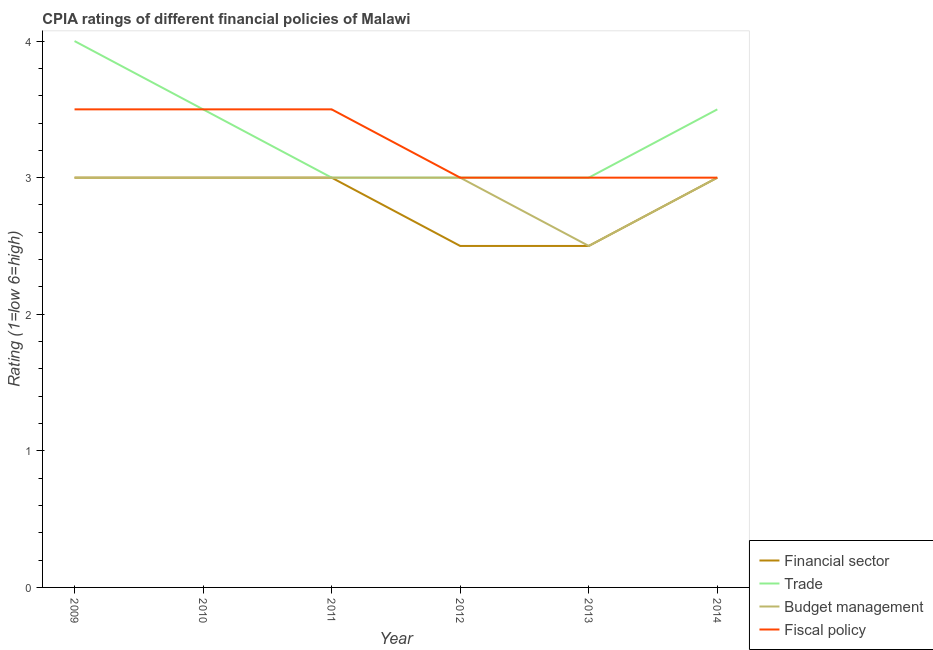Does the line corresponding to cpia rating of budget management intersect with the line corresponding to cpia rating of financial sector?
Your answer should be very brief. Yes. Is the number of lines equal to the number of legend labels?
Make the answer very short. Yes. Across all years, what is the maximum cpia rating of budget management?
Offer a very short reply. 3. In which year was the cpia rating of fiscal policy maximum?
Provide a succinct answer. 2009. What is the difference between the cpia rating of fiscal policy in 2009 and that in 2012?
Provide a succinct answer. 0.5. What is the difference between the cpia rating of budget management in 2014 and the cpia rating of trade in 2012?
Your answer should be very brief. 0. What is the average cpia rating of budget management per year?
Ensure brevity in your answer.  2.92. In the year 2009, what is the difference between the cpia rating of trade and cpia rating of financial sector?
Your answer should be compact. 1. In how many years, is the cpia rating of fiscal policy greater than 0.8?
Your answer should be compact. 6. What is the ratio of the cpia rating of trade in 2009 to that in 2011?
Offer a terse response. 1.33. Is the cpia rating of financial sector in 2010 less than that in 2012?
Make the answer very short. No. Is it the case that in every year, the sum of the cpia rating of fiscal policy and cpia rating of budget management is greater than the sum of cpia rating of trade and cpia rating of financial sector?
Your answer should be very brief. No. Is it the case that in every year, the sum of the cpia rating of financial sector and cpia rating of trade is greater than the cpia rating of budget management?
Offer a very short reply. Yes. Does the cpia rating of financial sector monotonically increase over the years?
Make the answer very short. No. Is the cpia rating of budget management strictly greater than the cpia rating of financial sector over the years?
Offer a very short reply. No. Is the cpia rating of trade strictly less than the cpia rating of financial sector over the years?
Offer a very short reply. No. How many lines are there?
Your response must be concise. 4. How many years are there in the graph?
Make the answer very short. 6. What is the difference between two consecutive major ticks on the Y-axis?
Your response must be concise. 1. What is the title of the graph?
Keep it short and to the point. CPIA ratings of different financial policies of Malawi. Does "Methodology assessment" appear as one of the legend labels in the graph?
Ensure brevity in your answer.  No. What is the Rating (1=low 6=high) in Fiscal policy in 2009?
Your answer should be very brief. 3.5. What is the Rating (1=low 6=high) of Financial sector in 2010?
Your response must be concise. 3. What is the Rating (1=low 6=high) of Financial sector in 2011?
Offer a very short reply. 3. What is the Rating (1=low 6=high) in Trade in 2011?
Your answer should be very brief. 3. What is the Rating (1=low 6=high) of Financial sector in 2012?
Provide a succinct answer. 2.5. What is the Rating (1=low 6=high) of Budget management in 2012?
Keep it short and to the point. 3. What is the Rating (1=low 6=high) of Financial sector in 2013?
Offer a terse response. 2.5. What is the Rating (1=low 6=high) of Financial sector in 2014?
Keep it short and to the point. 3. What is the Rating (1=low 6=high) of Budget management in 2014?
Give a very brief answer. 3. What is the Rating (1=low 6=high) of Fiscal policy in 2014?
Keep it short and to the point. 3. Across all years, what is the maximum Rating (1=low 6=high) in Financial sector?
Offer a very short reply. 3. Across all years, what is the maximum Rating (1=low 6=high) of Trade?
Ensure brevity in your answer.  4. Across all years, what is the maximum Rating (1=low 6=high) of Budget management?
Ensure brevity in your answer.  3. Across all years, what is the minimum Rating (1=low 6=high) of Financial sector?
Your answer should be compact. 2.5. Across all years, what is the minimum Rating (1=low 6=high) in Fiscal policy?
Your answer should be very brief. 3. What is the total Rating (1=low 6=high) of Trade in the graph?
Provide a short and direct response. 20. What is the total Rating (1=low 6=high) in Budget management in the graph?
Keep it short and to the point. 17.5. What is the difference between the Rating (1=low 6=high) in Financial sector in 2009 and that in 2011?
Offer a very short reply. 0. What is the difference between the Rating (1=low 6=high) of Budget management in 2009 and that in 2011?
Give a very brief answer. 0. What is the difference between the Rating (1=low 6=high) of Fiscal policy in 2009 and that in 2011?
Make the answer very short. 0. What is the difference between the Rating (1=low 6=high) in Financial sector in 2009 and that in 2012?
Offer a terse response. 0.5. What is the difference between the Rating (1=low 6=high) in Fiscal policy in 2009 and that in 2012?
Make the answer very short. 0.5. What is the difference between the Rating (1=low 6=high) of Fiscal policy in 2009 and that in 2013?
Give a very brief answer. 0.5. What is the difference between the Rating (1=low 6=high) in Financial sector in 2009 and that in 2014?
Offer a terse response. 0. What is the difference between the Rating (1=low 6=high) in Budget management in 2009 and that in 2014?
Make the answer very short. 0. What is the difference between the Rating (1=low 6=high) of Fiscal policy in 2009 and that in 2014?
Ensure brevity in your answer.  0.5. What is the difference between the Rating (1=low 6=high) in Financial sector in 2010 and that in 2011?
Your answer should be compact. 0. What is the difference between the Rating (1=low 6=high) in Budget management in 2010 and that in 2011?
Make the answer very short. 0. What is the difference between the Rating (1=low 6=high) in Fiscal policy in 2010 and that in 2011?
Ensure brevity in your answer.  0. What is the difference between the Rating (1=low 6=high) of Fiscal policy in 2010 and that in 2012?
Your answer should be very brief. 0.5. What is the difference between the Rating (1=low 6=high) of Financial sector in 2010 and that in 2013?
Ensure brevity in your answer.  0.5. What is the difference between the Rating (1=low 6=high) in Budget management in 2010 and that in 2013?
Provide a short and direct response. 0.5. What is the difference between the Rating (1=low 6=high) of Fiscal policy in 2010 and that in 2014?
Make the answer very short. 0.5. What is the difference between the Rating (1=low 6=high) in Financial sector in 2011 and that in 2012?
Ensure brevity in your answer.  0.5. What is the difference between the Rating (1=low 6=high) in Trade in 2011 and that in 2013?
Provide a short and direct response. 0. What is the difference between the Rating (1=low 6=high) of Financial sector in 2011 and that in 2014?
Offer a very short reply. 0. What is the difference between the Rating (1=low 6=high) in Trade in 2011 and that in 2014?
Make the answer very short. -0.5. What is the difference between the Rating (1=low 6=high) in Budget management in 2011 and that in 2014?
Ensure brevity in your answer.  0. What is the difference between the Rating (1=low 6=high) in Fiscal policy in 2011 and that in 2014?
Your answer should be very brief. 0.5. What is the difference between the Rating (1=low 6=high) of Trade in 2012 and that in 2013?
Your answer should be compact. 0. What is the difference between the Rating (1=low 6=high) in Budget management in 2012 and that in 2013?
Your answer should be very brief. 0.5. What is the difference between the Rating (1=low 6=high) of Budget management in 2012 and that in 2014?
Keep it short and to the point. 0. What is the difference between the Rating (1=low 6=high) in Financial sector in 2013 and that in 2014?
Give a very brief answer. -0.5. What is the difference between the Rating (1=low 6=high) in Financial sector in 2009 and the Rating (1=low 6=high) in Trade in 2010?
Offer a terse response. -0.5. What is the difference between the Rating (1=low 6=high) in Financial sector in 2009 and the Rating (1=low 6=high) in Fiscal policy in 2010?
Your response must be concise. -0.5. What is the difference between the Rating (1=low 6=high) in Trade in 2009 and the Rating (1=low 6=high) in Fiscal policy in 2010?
Your response must be concise. 0.5. What is the difference between the Rating (1=low 6=high) of Budget management in 2009 and the Rating (1=low 6=high) of Fiscal policy in 2010?
Offer a very short reply. -0.5. What is the difference between the Rating (1=low 6=high) in Financial sector in 2009 and the Rating (1=low 6=high) in Trade in 2011?
Offer a very short reply. 0. What is the difference between the Rating (1=low 6=high) of Financial sector in 2009 and the Rating (1=low 6=high) of Budget management in 2011?
Offer a terse response. 0. What is the difference between the Rating (1=low 6=high) in Financial sector in 2009 and the Rating (1=low 6=high) in Fiscal policy in 2011?
Keep it short and to the point. -0.5. What is the difference between the Rating (1=low 6=high) in Trade in 2009 and the Rating (1=low 6=high) in Budget management in 2011?
Provide a succinct answer. 1. What is the difference between the Rating (1=low 6=high) of Trade in 2009 and the Rating (1=low 6=high) of Fiscal policy in 2011?
Your answer should be very brief. 0.5. What is the difference between the Rating (1=low 6=high) in Financial sector in 2009 and the Rating (1=low 6=high) in Fiscal policy in 2012?
Make the answer very short. 0. What is the difference between the Rating (1=low 6=high) of Trade in 2009 and the Rating (1=low 6=high) of Budget management in 2012?
Provide a short and direct response. 1. What is the difference between the Rating (1=low 6=high) of Budget management in 2009 and the Rating (1=low 6=high) of Fiscal policy in 2013?
Ensure brevity in your answer.  0. What is the difference between the Rating (1=low 6=high) of Financial sector in 2009 and the Rating (1=low 6=high) of Budget management in 2014?
Your answer should be very brief. 0. What is the difference between the Rating (1=low 6=high) in Financial sector in 2009 and the Rating (1=low 6=high) in Fiscal policy in 2014?
Your response must be concise. 0. What is the difference between the Rating (1=low 6=high) in Trade in 2009 and the Rating (1=low 6=high) in Budget management in 2014?
Your response must be concise. 1. What is the difference between the Rating (1=low 6=high) in Trade in 2009 and the Rating (1=low 6=high) in Fiscal policy in 2014?
Offer a very short reply. 1. What is the difference between the Rating (1=low 6=high) in Financial sector in 2010 and the Rating (1=low 6=high) in Fiscal policy in 2011?
Your answer should be compact. -0.5. What is the difference between the Rating (1=low 6=high) in Trade in 2010 and the Rating (1=low 6=high) in Fiscal policy in 2011?
Provide a short and direct response. 0. What is the difference between the Rating (1=low 6=high) of Budget management in 2010 and the Rating (1=low 6=high) of Fiscal policy in 2011?
Offer a very short reply. -0.5. What is the difference between the Rating (1=low 6=high) of Financial sector in 2010 and the Rating (1=low 6=high) of Trade in 2012?
Provide a short and direct response. 0. What is the difference between the Rating (1=low 6=high) in Financial sector in 2010 and the Rating (1=low 6=high) in Budget management in 2012?
Provide a succinct answer. 0. What is the difference between the Rating (1=low 6=high) of Financial sector in 2010 and the Rating (1=low 6=high) of Fiscal policy in 2012?
Make the answer very short. 0. What is the difference between the Rating (1=low 6=high) of Trade in 2010 and the Rating (1=low 6=high) of Budget management in 2012?
Offer a terse response. 0.5. What is the difference between the Rating (1=low 6=high) of Budget management in 2010 and the Rating (1=low 6=high) of Fiscal policy in 2012?
Provide a short and direct response. 0. What is the difference between the Rating (1=low 6=high) in Trade in 2010 and the Rating (1=low 6=high) in Fiscal policy in 2013?
Keep it short and to the point. 0.5. What is the difference between the Rating (1=low 6=high) of Financial sector in 2010 and the Rating (1=low 6=high) of Trade in 2014?
Offer a terse response. -0.5. What is the difference between the Rating (1=low 6=high) of Financial sector in 2010 and the Rating (1=low 6=high) of Budget management in 2014?
Ensure brevity in your answer.  0. What is the difference between the Rating (1=low 6=high) of Trade in 2010 and the Rating (1=low 6=high) of Budget management in 2014?
Keep it short and to the point. 0.5. What is the difference between the Rating (1=low 6=high) in Trade in 2010 and the Rating (1=low 6=high) in Fiscal policy in 2014?
Keep it short and to the point. 0.5. What is the difference between the Rating (1=low 6=high) of Financial sector in 2011 and the Rating (1=low 6=high) of Fiscal policy in 2012?
Provide a succinct answer. 0. What is the difference between the Rating (1=low 6=high) of Trade in 2011 and the Rating (1=low 6=high) of Budget management in 2012?
Give a very brief answer. 0. What is the difference between the Rating (1=low 6=high) of Financial sector in 2011 and the Rating (1=low 6=high) of Trade in 2013?
Keep it short and to the point. 0. What is the difference between the Rating (1=low 6=high) of Financial sector in 2011 and the Rating (1=low 6=high) of Budget management in 2013?
Ensure brevity in your answer.  0.5. What is the difference between the Rating (1=low 6=high) of Financial sector in 2011 and the Rating (1=low 6=high) of Fiscal policy in 2013?
Your response must be concise. 0. What is the difference between the Rating (1=low 6=high) of Trade in 2011 and the Rating (1=low 6=high) of Budget management in 2013?
Your response must be concise. 0.5. What is the difference between the Rating (1=low 6=high) in Financial sector in 2011 and the Rating (1=low 6=high) in Fiscal policy in 2014?
Give a very brief answer. 0. What is the difference between the Rating (1=low 6=high) of Trade in 2011 and the Rating (1=low 6=high) of Budget management in 2014?
Ensure brevity in your answer.  0. What is the difference between the Rating (1=low 6=high) of Budget management in 2011 and the Rating (1=low 6=high) of Fiscal policy in 2014?
Offer a terse response. 0. What is the difference between the Rating (1=low 6=high) of Financial sector in 2012 and the Rating (1=low 6=high) of Budget management in 2013?
Your answer should be very brief. 0. What is the difference between the Rating (1=low 6=high) of Trade in 2012 and the Rating (1=low 6=high) of Fiscal policy in 2013?
Ensure brevity in your answer.  0. What is the difference between the Rating (1=low 6=high) of Budget management in 2012 and the Rating (1=low 6=high) of Fiscal policy in 2013?
Provide a short and direct response. 0. What is the difference between the Rating (1=low 6=high) of Financial sector in 2012 and the Rating (1=low 6=high) of Budget management in 2014?
Offer a terse response. -0.5. What is the difference between the Rating (1=low 6=high) in Financial sector in 2012 and the Rating (1=low 6=high) in Fiscal policy in 2014?
Keep it short and to the point. -0.5. What is the difference between the Rating (1=low 6=high) in Financial sector in 2013 and the Rating (1=low 6=high) in Fiscal policy in 2014?
Make the answer very short. -0.5. What is the difference between the Rating (1=low 6=high) of Trade in 2013 and the Rating (1=low 6=high) of Budget management in 2014?
Offer a very short reply. 0. What is the difference between the Rating (1=low 6=high) of Budget management in 2013 and the Rating (1=low 6=high) of Fiscal policy in 2014?
Offer a very short reply. -0.5. What is the average Rating (1=low 6=high) of Financial sector per year?
Ensure brevity in your answer.  2.83. What is the average Rating (1=low 6=high) of Budget management per year?
Ensure brevity in your answer.  2.92. What is the average Rating (1=low 6=high) of Fiscal policy per year?
Offer a terse response. 3.25. In the year 2009, what is the difference between the Rating (1=low 6=high) of Financial sector and Rating (1=low 6=high) of Fiscal policy?
Offer a terse response. -0.5. In the year 2009, what is the difference between the Rating (1=low 6=high) in Trade and Rating (1=low 6=high) in Budget management?
Your response must be concise. 1. In the year 2009, what is the difference between the Rating (1=low 6=high) of Trade and Rating (1=low 6=high) of Fiscal policy?
Ensure brevity in your answer.  0.5. In the year 2010, what is the difference between the Rating (1=low 6=high) in Financial sector and Rating (1=low 6=high) in Budget management?
Keep it short and to the point. 0. In the year 2010, what is the difference between the Rating (1=low 6=high) of Trade and Rating (1=low 6=high) of Budget management?
Keep it short and to the point. 0.5. In the year 2010, what is the difference between the Rating (1=low 6=high) of Trade and Rating (1=low 6=high) of Fiscal policy?
Keep it short and to the point. 0. In the year 2010, what is the difference between the Rating (1=low 6=high) in Budget management and Rating (1=low 6=high) in Fiscal policy?
Your answer should be very brief. -0.5. In the year 2011, what is the difference between the Rating (1=low 6=high) of Financial sector and Rating (1=low 6=high) of Trade?
Your answer should be compact. 0. In the year 2011, what is the difference between the Rating (1=low 6=high) in Financial sector and Rating (1=low 6=high) in Budget management?
Your answer should be compact. 0. In the year 2011, what is the difference between the Rating (1=low 6=high) of Trade and Rating (1=low 6=high) of Fiscal policy?
Provide a short and direct response. -0.5. In the year 2011, what is the difference between the Rating (1=low 6=high) in Budget management and Rating (1=low 6=high) in Fiscal policy?
Provide a short and direct response. -0.5. In the year 2012, what is the difference between the Rating (1=low 6=high) in Financial sector and Rating (1=low 6=high) in Budget management?
Offer a very short reply. -0.5. In the year 2012, what is the difference between the Rating (1=low 6=high) of Trade and Rating (1=low 6=high) of Fiscal policy?
Offer a very short reply. 0. In the year 2012, what is the difference between the Rating (1=low 6=high) in Budget management and Rating (1=low 6=high) in Fiscal policy?
Give a very brief answer. 0. In the year 2013, what is the difference between the Rating (1=low 6=high) in Financial sector and Rating (1=low 6=high) in Trade?
Your answer should be compact. -0.5. In the year 2013, what is the difference between the Rating (1=low 6=high) of Financial sector and Rating (1=low 6=high) of Fiscal policy?
Give a very brief answer. -0.5. In the year 2014, what is the difference between the Rating (1=low 6=high) of Financial sector and Rating (1=low 6=high) of Trade?
Your response must be concise. -0.5. In the year 2014, what is the difference between the Rating (1=low 6=high) of Trade and Rating (1=low 6=high) of Fiscal policy?
Offer a terse response. 0.5. What is the ratio of the Rating (1=low 6=high) of Budget management in 2009 to that in 2010?
Offer a terse response. 1. What is the ratio of the Rating (1=low 6=high) of Fiscal policy in 2009 to that in 2011?
Give a very brief answer. 1. What is the ratio of the Rating (1=low 6=high) of Fiscal policy in 2009 to that in 2012?
Keep it short and to the point. 1.17. What is the ratio of the Rating (1=low 6=high) in Financial sector in 2009 to that in 2014?
Offer a terse response. 1. What is the ratio of the Rating (1=low 6=high) in Budget management in 2009 to that in 2014?
Your answer should be compact. 1. What is the ratio of the Rating (1=low 6=high) in Financial sector in 2010 to that in 2011?
Your response must be concise. 1. What is the ratio of the Rating (1=low 6=high) of Budget management in 2010 to that in 2011?
Keep it short and to the point. 1. What is the ratio of the Rating (1=low 6=high) in Fiscal policy in 2010 to that in 2011?
Make the answer very short. 1. What is the ratio of the Rating (1=low 6=high) of Trade in 2010 to that in 2012?
Offer a terse response. 1.17. What is the ratio of the Rating (1=low 6=high) in Budget management in 2010 to that in 2012?
Provide a short and direct response. 1. What is the ratio of the Rating (1=low 6=high) of Fiscal policy in 2010 to that in 2012?
Offer a very short reply. 1.17. What is the ratio of the Rating (1=low 6=high) in Trade in 2010 to that in 2013?
Give a very brief answer. 1.17. What is the ratio of the Rating (1=low 6=high) in Budget management in 2010 to that in 2013?
Provide a short and direct response. 1.2. What is the ratio of the Rating (1=low 6=high) of Trade in 2010 to that in 2014?
Your response must be concise. 1. What is the ratio of the Rating (1=low 6=high) of Budget management in 2010 to that in 2014?
Your answer should be very brief. 1. What is the ratio of the Rating (1=low 6=high) in Budget management in 2011 to that in 2012?
Provide a short and direct response. 1. What is the ratio of the Rating (1=low 6=high) of Financial sector in 2011 to that in 2013?
Keep it short and to the point. 1.2. What is the ratio of the Rating (1=low 6=high) of Trade in 2011 to that in 2014?
Give a very brief answer. 0.86. What is the ratio of the Rating (1=low 6=high) in Financial sector in 2012 to that in 2013?
Your answer should be very brief. 1. What is the ratio of the Rating (1=low 6=high) in Fiscal policy in 2012 to that in 2013?
Keep it short and to the point. 1. What is the ratio of the Rating (1=low 6=high) in Trade in 2012 to that in 2014?
Your answer should be compact. 0.86. What is the ratio of the Rating (1=low 6=high) of Financial sector in 2013 to that in 2014?
Make the answer very short. 0.83. What is the ratio of the Rating (1=low 6=high) in Trade in 2013 to that in 2014?
Provide a succinct answer. 0.86. What is the ratio of the Rating (1=low 6=high) in Budget management in 2013 to that in 2014?
Give a very brief answer. 0.83. What is the difference between the highest and the second highest Rating (1=low 6=high) of Trade?
Offer a very short reply. 0.5. What is the difference between the highest and the second highest Rating (1=low 6=high) in Budget management?
Your answer should be very brief. 0. What is the difference between the highest and the second highest Rating (1=low 6=high) in Fiscal policy?
Your response must be concise. 0. What is the difference between the highest and the lowest Rating (1=low 6=high) in Financial sector?
Your answer should be very brief. 0.5. What is the difference between the highest and the lowest Rating (1=low 6=high) of Budget management?
Offer a very short reply. 0.5. What is the difference between the highest and the lowest Rating (1=low 6=high) in Fiscal policy?
Your response must be concise. 0.5. 